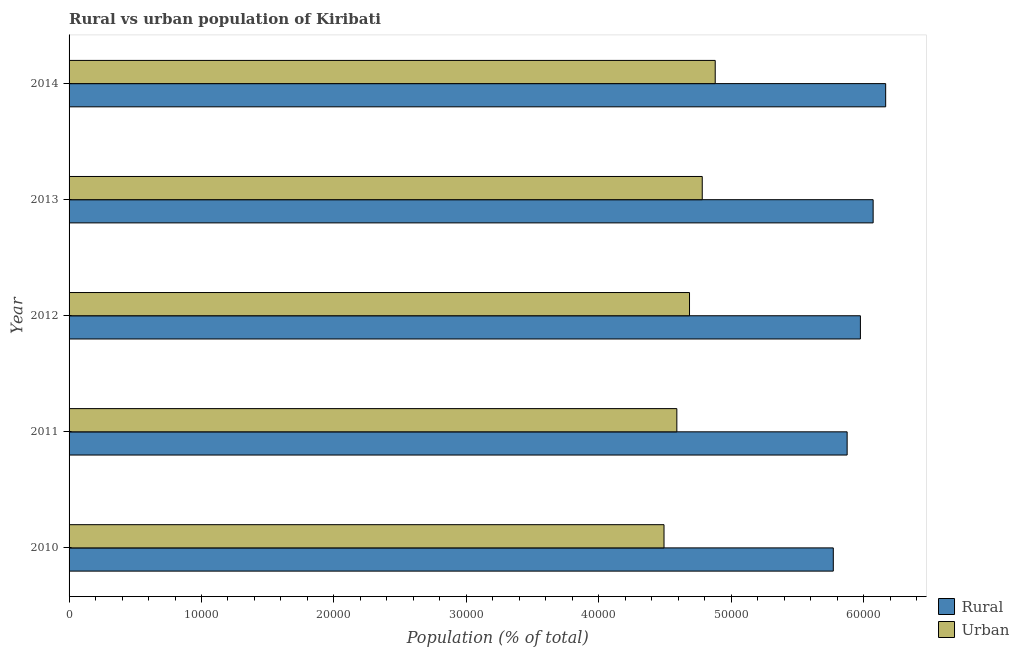How many different coloured bars are there?
Offer a very short reply. 2. How many groups of bars are there?
Your response must be concise. 5. How many bars are there on the 4th tick from the top?
Offer a very short reply. 2. How many bars are there on the 3rd tick from the bottom?
Make the answer very short. 2. What is the rural population density in 2013?
Make the answer very short. 6.07e+04. Across all years, what is the maximum urban population density?
Ensure brevity in your answer.  4.88e+04. Across all years, what is the minimum urban population density?
Give a very brief answer. 4.49e+04. In which year was the urban population density maximum?
Make the answer very short. 2014. In which year was the urban population density minimum?
Offer a terse response. 2010. What is the total rural population density in the graph?
Make the answer very short. 2.99e+05. What is the difference between the rural population density in 2011 and that in 2014?
Give a very brief answer. -2910. What is the difference between the urban population density in 2013 and the rural population density in 2011?
Your answer should be compact. -1.09e+04. What is the average rural population density per year?
Provide a short and direct response. 5.97e+04. In the year 2012, what is the difference between the urban population density and rural population density?
Your answer should be very brief. -1.29e+04. What is the difference between the highest and the second highest rural population density?
Give a very brief answer. 947. What is the difference between the highest and the lowest rural population density?
Your response must be concise. 3956. What does the 2nd bar from the top in 2011 represents?
Make the answer very short. Rural. What does the 2nd bar from the bottom in 2011 represents?
Make the answer very short. Urban. How many years are there in the graph?
Provide a short and direct response. 5. Does the graph contain any zero values?
Offer a terse response. No. Does the graph contain grids?
Provide a short and direct response. No. Where does the legend appear in the graph?
Provide a short and direct response. Bottom right. What is the title of the graph?
Make the answer very short. Rural vs urban population of Kiribati. Does "Largest city" appear as one of the legend labels in the graph?
Offer a very short reply. No. What is the label or title of the X-axis?
Make the answer very short. Population (% of total). What is the Population (% of total) of Rural in 2010?
Provide a short and direct response. 5.77e+04. What is the Population (% of total) in Urban in 2010?
Your answer should be compact. 4.49e+04. What is the Population (% of total) in Rural in 2011?
Your answer should be very brief. 5.88e+04. What is the Population (% of total) in Urban in 2011?
Ensure brevity in your answer.  4.59e+04. What is the Population (% of total) in Rural in 2012?
Ensure brevity in your answer.  5.98e+04. What is the Population (% of total) of Urban in 2012?
Provide a succinct answer. 4.69e+04. What is the Population (% of total) in Rural in 2013?
Provide a succinct answer. 6.07e+04. What is the Population (% of total) of Urban in 2013?
Your answer should be very brief. 4.78e+04. What is the Population (% of total) in Rural in 2014?
Keep it short and to the point. 6.17e+04. What is the Population (% of total) in Urban in 2014?
Your response must be concise. 4.88e+04. Across all years, what is the maximum Population (% of total) of Rural?
Your response must be concise. 6.17e+04. Across all years, what is the maximum Population (% of total) of Urban?
Your answer should be very brief. 4.88e+04. Across all years, what is the minimum Population (% of total) in Rural?
Provide a succinct answer. 5.77e+04. Across all years, what is the minimum Population (% of total) in Urban?
Your response must be concise. 4.49e+04. What is the total Population (% of total) in Rural in the graph?
Your answer should be very brief. 2.99e+05. What is the total Population (% of total) of Urban in the graph?
Ensure brevity in your answer.  2.34e+05. What is the difference between the Population (% of total) in Rural in 2010 and that in 2011?
Provide a short and direct response. -1046. What is the difference between the Population (% of total) of Urban in 2010 and that in 2011?
Your response must be concise. -968. What is the difference between the Population (% of total) in Rural in 2010 and that in 2012?
Offer a terse response. -2047. What is the difference between the Population (% of total) of Urban in 2010 and that in 2012?
Your response must be concise. -1925. What is the difference between the Population (% of total) of Rural in 2010 and that in 2013?
Ensure brevity in your answer.  -3009. What is the difference between the Population (% of total) in Urban in 2010 and that in 2013?
Offer a terse response. -2887. What is the difference between the Population (% of total) in Rural in 2010 and that in 2014?
Provide a succinct answer. -3956. What is the difference between the Population (% of total) of Urban in 2010 and that in 2014?
Ensure brevity in your answer.  -3866. What is the difference between the Population (% of total) of Rural in 2011 and that in 2012?
Provide a short and direct response. -1001. What is the difference between the Population (% of total) in Urban in 2011 and that in 2012?
Ensure brevity in your answer.  -957. What is the difference between the Population (% of total) in Rural in 2011 and that in 2013?
Ensure brevity in your answer.  -1963. What is the difference between the Population (% of total) in Urban in 2011 and that in 2013?
Offer a very short reply. -1919. What is the difference between the Population (% of total) in Rural in 2011 and that in 2014?
Give a very brief answer. -2910. What is the difference between the Population (% of total) of Urban in 2011 and that in 2014?
Provide a short and direct response. -2898. What is the difference between the Population (% of total) of Rural in 2012 and that in 2013?
Give a very brief answer. -962. What is the difference between the Population (% of total) in Urban in 2012 and that in 2013?
Keep it short and to the point. -962. What is the difference between the Population (% of total) of Rural in 2012 and that in 2014?
Your response must be concise. -1909. What is the difference between the Population (% of total) of Urban in 2012 and that in 2014?
Provide a short and direct response. -1941. What is the difference between the Population (% of total) in Rural in 2013 and that in 2014?
Your answer should be compact. -947. What is the difference between the Population (% of total) of Urban in 2013 and that in 2014?
Your answer should be very brief. -979. What is the difference between the Population (% of total) of Rural in 2010 and the Population (% of total) of Urban in 2011?
Provide a short and direct response. 1.18e+04. What is the difference between the Population (% of total) of Rural in 2010 and the Population (% of total) of Urban in 2012?
Your answer should be very brief. 1.09e+04. What is the difference between the Population (% of total) of Rural in 2010 and the Population (% of total) of Urban in 2013?
Make the answer very short. 9897. What is the difference between the Population (% of total) of Rural in 2010 and the Population (% of total) of Urban in 2014?
Keep it short and to the point. 8918. What is the difference between the Population (% of total) in Rural in 2011 and the Population (% of total) in Urban in 2012?
Offer a very short reply. 1.19e+04. What is the difference between the Population (% of total) of Rural in 2011 and the Population (% of total) of Urban in 2013?
Make the answer very short. 1.09e+04. What is the difference between the Population (% of total) of Rural in 2011 and the Population (% of total) of Urban in 2014?
Ensure brevity in your answer.  9964. What is the difference between the Population (% of total) in Rural in 2012 and the Population (% of total) in Urban in 2013?
Ensure brevity in your answer.  1.19e+04. What is the difference between the Population (% of total) of Rural in 2012 and the Population (% of total) of Urban in 2014?
Provide a succinct answer. 1.10e+04. What is the difference between the Population (% of total) of Rural in 2013 and the Population (% of total) of Urban in 2014?
Ensure brevity in your answer.  1.19e+04. What is the average Population (% of total) of Rural per year?
Provide a succinct answer. 5.97e+04. What is the average Population (% of total) in Urban per year?
Your answer should be compact. 4.69e+04. In the year 2010, what is the difference between the Population (% of total) of Rural and Population (% of total) of Urban?
Keep it short and to the point. 1.28e+04. In the year 2011, what is the difference between the Population (% of total) in Rural and Population (% of total) in Urban?
Make the answer very short. 1.29e+04. In the year 2012, what is the difference between the Population (% of total) in Rural and Population (% of total) in Urban?
Offer a terse response. 1.29e+04. In the year 2013, what is the difference between the Population (% of total) in Rural and Population (% of total) in Urban?
Your answer should be very brief. 1.29e+04. In the year 2014, what is the difference between the Population (% of total) of Rural and Population (% of total) of Urban?
Make the answer very short. 1.29e+04. What is the ratio of the Population (% of total) in Rural in 2010 to that in 2011?
Make the answer very short. 0.98. What is the ratio of the Population (% of total) of Urban in 2010 to that in 2011?
Offer a very short reply. 0.98. What is the ratio of the Population (% of total) in Rural in 2010 to that in 2012?
Offer a terse response. 0.97. What is the ratio of the Population (% of total) of Urban in 2010 to that in 2012?
Offer a very short reply. 0.96. What is the ratio of the Population (% of total) in Rural in 2010 to that in 2013?
Provide a succinct answer. 0.95. What is the ratio of the Population (% of total) in Urban in 2010 to that in 2013?
Your answer should be very brief. 0.94. What is the ratio of the Population (% of total) in Rural in 2010 to that in 2014?
Offer a very short reply. 0.94. What is the ratio of the Population (% of total) in Urban in 2010 to that in 2014?
Ensure brevity in your answer.  0.92. What is the ratio of the Population (% of total) of Rural in 2011 to that in 2012?
Offer a terse response. 0.98. What is the ratio of the Population (% of total) of Urban in 2011 to that in 2012?
Keep it short and to the point. 0.98. What is the ratio of the Population (% of total) in Rural in 2011 to that in 2013?
Make the answer very short. 0.97. What is the ratio of the Population (% of total) of Urban in 2011 to that in 2013?
Your response must be concise. 0.96. What is the ratio of the Population (% of total) of Rural in 2011 to that in 2014?
Provide a short and direct response. 0.95. What is the ratio of the Population (% of total) of Urban in 2011 to that in 2014?
Your answer should be very brief. 0.94. What is the ratio of the Population (% of total) of Rural in 2012 to that in 2013?
Your response must be concise. 0.98. What is the ratio of the Population (% of total) in Urban in 2012 to that in 2013?
Your answer should be very brief. 0.98. What is the ratio of the Population (% of total) of Urban in 2012 to that in 2014?
Keep it short and to the point. 0.96. What is the ratio of the Population (% of total) of Rural in 2013 to that in 2014?
Keep it short and to the point. 0.98. What is the ratio of the Population (% of total) of Urban in 2013 to that in 2014?
Your answer should be compact. 0.98. What is the difference between the highest and the second highest Population (% of total) in Rural?
Your response must be concise. 947. What is the difference between the highest and the second highest Population (% of total) in Urban?
Offer a very short reply. 979. What is the difference between the highest and the lowest Population (% of total) in Rural?
Your answer should be compact. 3956. What is the difference between the highest and the lowest Population (% of total) in Urban?
Your answer should be compact. 3866. 